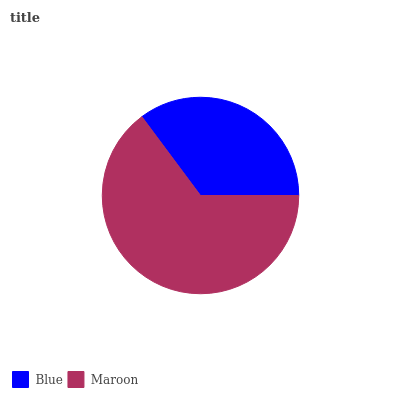Is Blue the minimum?
Answer yes or no. Yes. Is Maroon the maximum?
Answer yes or no. Yes. Is Maroon the minimum?
Answer yes or no. No. Is Maroon greater than Blue?
Answer yes or no. Yes. Is Blue less than Maroon?
Answer yes or no. Yes. Is Blue greater than Maroon?
Answer yes or no. No. Is Maroon less than Blue?
Answer yes or no. No. Is Maroon the high median?
Answer yes or no. Yes. Is Blue the low median?
Answer yes or no. Yes. Is Blue the high median?
Answer yes or no. No. Is Maroon the low median?
Answer yes or no. No. 